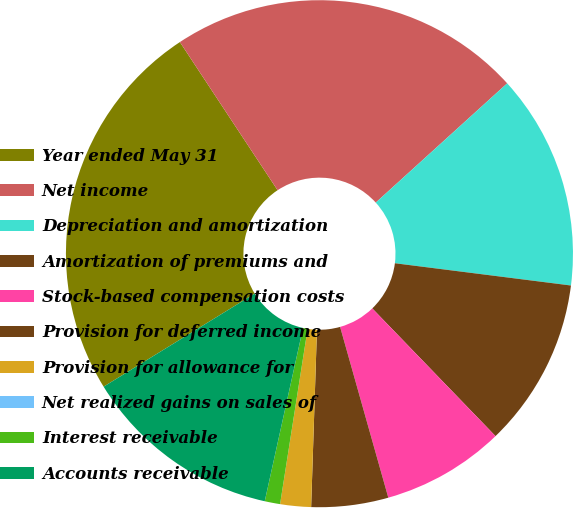Convert chart. <chart><loc_0><loc_0><loc_500><loc_500><pie_chart><fcel>Year ended May 31<fcel>Net income<fcel>Depreciation and amortization<fcel>Amortization of premiums and<fcel>Stock-based compensation costs<fcel>Provision for deferred income<fcel>Provision for allowance for<fcel>Net realized gains on sales of<fcel>Interest receivable<fcel>Accounts receivable<nl><fcel>24.51%<fcel>22.55%<fcel>13.73%<fcel>10.78%<fcel>7.84%<fcel>4.9%<fcel>1.96%<fcel>0.0%<fcel>0.98%<fcel>12.75%<nl></chart> 